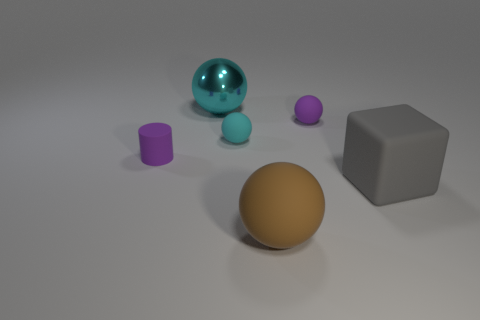Is there a small cyan rubber object that has the same shape as the shiny thing?
Provide a short and direct response. Yes. There is another tiny thing that is the same color as the shiny object; what is its material?
Your answer should be compact. Rubber. The cyan thing behind the purple matte object that is behind the small rubber cylinder is what shape?
Your response must be concise. Sphere. What number of other large brown balls are made of the same material as the brown ball?
Provide a succinct answer. 0. What is the color of the small cylinder that is made of the same material as the big gray cube?
Give a very brief answer. Purple. What is the size of the purple rubber object that is to the right of the tiny purple thing that is left of the purple rubber thing that is right of the cylinder?
Offer a terse response. Small. Are there fewer brown balls than big green rubber spheres?
Your answer should be compact. No. The big matte object that is the same shape as the shiny thing is what color?
Give a very brief answer. Brown. Is there a small purple object that is on the right side of the brown sphere that is to the right of the big ball that is behind the big gray thing?
Keep it short and to the point. Yes. Is the shape of the big cyan object the same as the gray thing?
Ensure brevity in your answer.  No. 